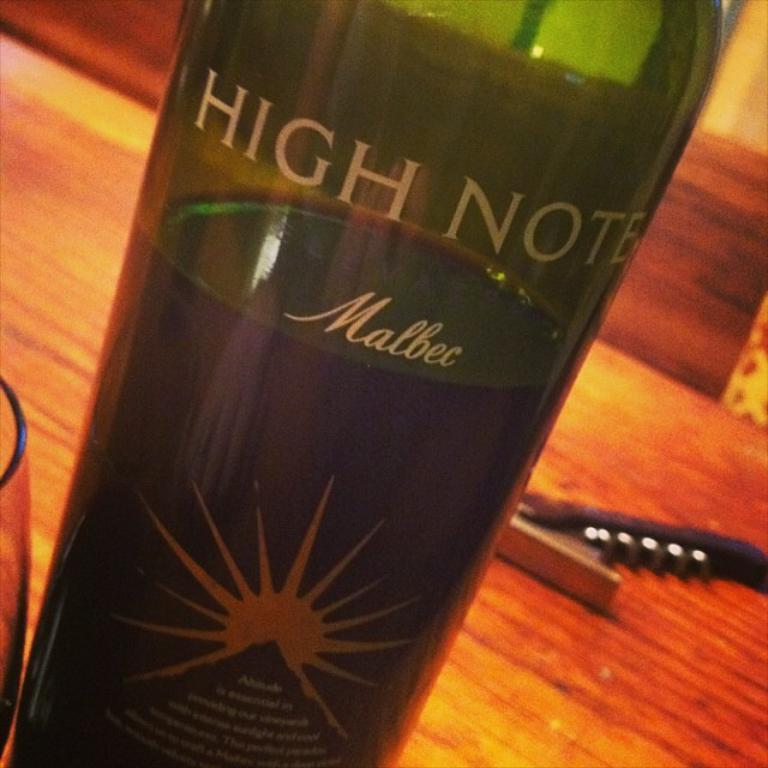Provide a one-sentence caption for the provided image. The bottle of High Note Malbec wine sits 2/3 full on the table near the corkscrew. 